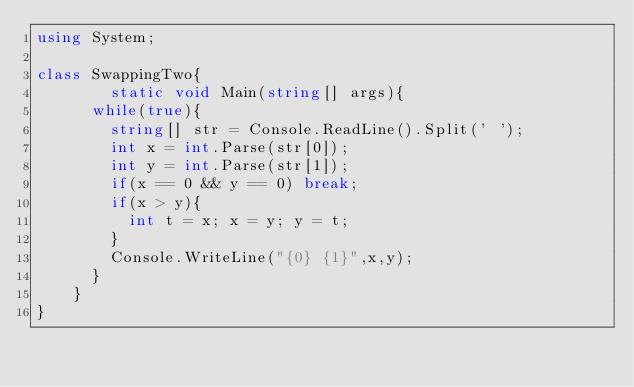Convert code to text. <code><loc_0><loc_0><loc_500><loc_500><_C#_>using System;

class SwappingTwo{
        static void Main(string[] args){
	  while(true){
	    string[] str = Console.ReadLine().Split(' ');
	    int x = int.Parse(str[0]);
	    int y = int.Parse(str[1]);
	    if(x == 0 && y == 0) break;
	    if(x > y){
	      int t = x; x = y; y = t;
	    }
	    Console.WriteLine("{0} {1}",x,y);
	  }
	}
}</code> 